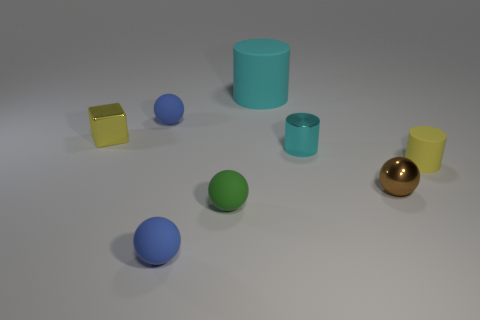Can you tell me the colors of the objects starting from the leftmost item? Certainly! From left to right, the colors are yellow (cube), blue (small sphere), blue (large cylinder), teal (small cylinder), green (sphere), and gold (sphere). 